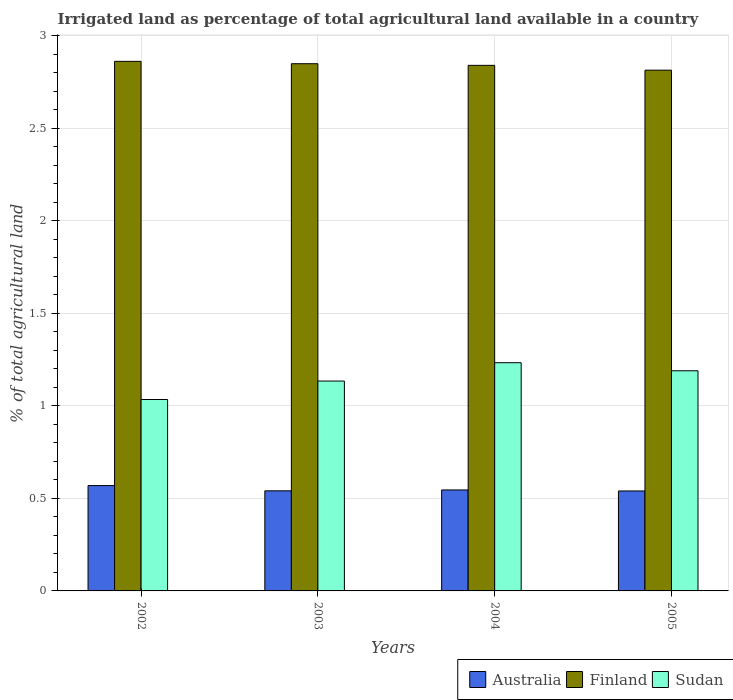Are the number of bars on each tick of the X-axis equal?
Ensure brevity in your answer.  Yes. How many bars are there on the 2nd tick from the left?
Keep it short and to the point. 3. How many bars are there on the 1st tick from the right?
Make the answer very short. 3. What is the label of the 1st group of bars from the left?
Your answer should be compact. 2002. In how many cases, is the number of bars for a given year not equal to the number of legend labels?
Your answer should be compact. 0. What is the percentage of irrigated land in Sudan in 2005?
Give a very brief answer. 1.19. Across all years, what is the maximum percentage of irrigated land in Australia?
Your answer should be very brief. 0.57. Across all years, what is the minimum percentage of irrigated land in Finland?
Offer a very short reply. 2.81. In which year was the percentage of irrigated land in Australia maximum?
Your answer should be very brief. 2002. In which year was the percentage of irrigated land in Australia minimum?
Offer a very short reply. 2005. What is the total percentage of irrigated land in Finland in the graph?
Your answer should be compact. 11.37. What is the difference between the percentage of irrigated land in Finland in 2003 and that in 2004?
Your answer should be very brief. 0.01. What is the difference between the percentage of irrigated land in Finland in 2002 and the percentage of irrigated land in Sudan in 2004?
Give a very brief answer. 1.63. What is the average percentage of irrigated land in Finland per year?
Your answer should be very brief. 2.84. In the year 2002, what is the difference between the percentage of irrigated land in Sudan and percentage of irrigated land in Finland?
Offer a terse response. -1.83. In how many years, is the percentage of irrigated land in Sudan greater than 2.3 %?
Ensure brevity in your answer.  0. What is the ratio of the percentage of irrigated land in Sudan in 2004 to that in 2005?
Your answer should be very brief. 1.04. What is the difference between the highest and the second highest percentage of irrigated land in Australia?
Ensure brevity in your answer.  0.02. What is the difference between the highest and the lowest percentage of irrigated land in Sudan?
Ensure brevity in your answer.  0.2. In how many years, is the percentage of irrigated land in Australia greater than the average percentage of irrigated land in Australia taken over all years?
Provide a succinct answer. 1. Is it the case that in every year, the sum of the percentage of irrigated land in Finland and percentage of irrigated land in Sudan is greater than the percentage of irrigated land in Australia?
Provide a short and direct response. Yes. Are all the bars in the graph horizontal?
Give a very brief answer. No. Are the values on the major ticks of Y-axis written in scientific E-notation?
Your response must be concise. No. How are the legend labels stacked?
Your answer should be compact. Horizontal. What is the title of the graph?
Provide a succinct answer. Irrigated land as percentage of total agricultural land available in a country. Does "Madagascar" appear as one of the legend labels in the graph?
Give a very brief answer. No. What is the label or title of the Y-axis?
Your response must be concise. % of total agricultural land. What is the % of total agricultural land of Australia in 2002?
Provide a succinct answer. 0.57. What is the % of total agricultural land in Finland in 2002?
Make the answer very short. 2.86. What is the % of total agricultural land of Sudan in 2002?
Provide a short and direct response. 1.03. What is the % of total agricultural land of Australia in 2003?
Provide a succinct answer. 0.54. What is the % of total agricultural land in Finland in 2003?
Offer a terse response. 2.85. What is the % of total agricultural land in Sudan in 2003?
Make the answer very short. 1.13. What is the % of total agricultural land in Australia in 2004?
Provide a succinct answer. 0.55. What is the % of total agricultural land in Finland in 2004?
Give a very brief answer. 2.84. What is the % of total agricultural land of Sudan in 2004?
Offer a very short reply. 1.23. What is the % of total agricultural land in Australia in 2005?
Your answer should be compact. 0.54. What is the % of total agricultural land in Finland in 2005?
Offer a very short reply. 2.81. What is the % of total agricultural land of Sudan in 2005?
Offer a terse response. 1.19. Across all years, what is the maximum % of total agricultural land of Australia?
Give a very brief answer. 0.57. Across all years, what is the maximum % of total agricultural land of Finland?
Make the answer very short. 2.86. Across all years, what is the maximum % of total agricultural land in Sudan?
Your response must be concise. 1.23. Across all years, what is the minimum % of total agricultural land of Australia?
Your answer should be very brief. 0.54. Across all years, what is the minimum % of total agricultural land in Finland?
Offer a terse response. 2.81. Across all years, what is the minimum % of total agricultural land in Sudan?
Keep it short and to the point. 1.03. What is the total % of total agricultural land in Australia in the graph?
Ensure brevity in your answer.  2.2. What is the total % of total agricultural land in Finland in the graph?
Your answer should be compact. 11.37. What is the total % of total agricultural land in Sudan in the graph?
Your answer should be very brief. 4.59. What is the difference between the % of total agricultural land of Australia in 2002 and that in 2003?
Offer a very short reply. 0.03. What is the difference between the % of total agricultural land in Finland in 2002 and that in 2003?
Keep it short and to the point. 0.01. What is the difference between the % of total agricultural land in Sudan in 2002 and that in 2003?
Your answer should be very brief. -0.1. What is the difference between the % of total agricultural land in Australia in 2002 and that in 2004?
Offer a very short reply. 0.02. What is the difference between the % of total agricultural land of Finland in 2002 and that in 2004?
Your answer should be very brief. 0.02. What is the difference between the % of total agricultural land in Sudan in 2002 and that in 2004?
Make the answer very short. -0.2. What is the difference between the % of total agricultural land in Australia in 2002 and that in 2005?
Your response must be concise. 0.03. What is the difference between the % of total agricultural land of Finland in 2002 and that in 2005?
Make the answer very short. 0.05. What is the difference between the % of total agricultural land of Sudan in 2002 and that in 2005?
Your response must be concise. -0.16. What is the difference between the % of total agricultural land in Australia in 2003 and that in 2004?
Give a very brief answer. -0. What is the difference between the % of total agricultural land of Finland in 2003 and that in 2004?
Ensure brevity in your answer.  0.01. What is the difference between the % of total agricultural land of Sudan in 2003 and that in 2004?
Ensure brevity in your answer.  -0.1. What is the difference between the % of total agricultural land in Australia in 2003 and that in 2005?
Your response must be concise. 0. What is the difference between the % of total agricultural land in Finland in 2003 and that in 2005?
Keep it short and to the point. 0.03. What is the difference between the % of total agricultural land of Sudan in 2003 and that in 2005?
Make the answer very short. -0.06. What is the difference between the % of total agricultural land in Australia in 2004 and that in 2005?
Keep it short and to the point. 0.01. What is the difference between the % of total agricultural land of Finland in 2004 and that in 2005?
Offer a terse response. 0.03. What is the difference between the % of total agricultural land in Sudan in 2004 and that in 2005?
Your answer should be very brief. 0.04. What is the difference between the % of total agricultural land of Australia in 2002 and the % of total agricultural land of Finland in 2003?
Your response must be concise. -2.28. What is the difference between the % of total agricultural land in Australia in 2002 and the % of total agricultural land in Sudan in 2003?
Offer a terse response. -0.56. What is the difference between the % of total agricultural land of Finland in 2002 and the % of total agricultural land of Sudan in 2003?
Your response must be concise. 1.73. What is the difference between the % of total agricultural land in Australia in 2002 and the % of total agricultural land in Finland in 2004?
Make the answer very short. -2.27. What is the difference between the % of total agricultural land of Australia in 2002 and the % of total agricultural land of Sudan in 2004?
Offer a terse response. -0.66. What is the difference between the % of total agricultural land in Finland in 2002 and the % of total agricultural land in Sudan in 2004?
Offer a very short reply. 1.63. What is the difference between the % of total agricultural land in Australia in 2002 and the % of total agricultural land in Finland in 2005?
Provide a succinct answer. -2.25. What is the difference between the % of total agricultural land of Australia in 2002 and the % of total agricultural land of Sudan in 2005?
Make the answer very short. -0.62. What is the difference between the % of total agricultural land in Finland in 2002 and the % of total agricultural land in Sudan in 2005?
Your answer should be compact. 1.67. What is the difference between the % of total agricultural land of Australia in 2003 and the % of total agricultural land of Finland in 2004?
Your answer should be compact. -2.3. What is the difference between the % of total agricultural land of Australia in 2003 and the % of total agricultural land of Sudan in 2004?
Your answer should be compact. -0.69. What is the difference between the % of total agricultural land in Finland in 2003 and the % of total agricultural land in Sudan in 2004?
Your response must be concise. 1.62. What is the difference between the % of total agricultural land in Australia in 2003 and the % of total agricultural land in Finland in 2005?
Your answer should be very brief. -2.27. What is the difference between the % of total agricultural land of Australia in 2003 and the % of total agricultural land of Sudan in 2005?
Your response must be concise. -0.65. What is the difference between the % of total agricultural land of Finland in 2003 and the % of total agricultural land of Sudan in 2005?
Offer a very short reply. 1.66. What is the difference between the % of total agricultural land in Australia in 2004 and the % of total agricultural land in Finland in 2005?
Offer a terse response. -2.27. What is the difference between the % of total agricultural land of Australia in 2004 and the % of total agricultural land of Sudan in 2005?
Provide a succinct answer. -0.64. What is the difference between the % of total agricultural land of Finland in 2004 and the % of total agricultural land of Sudan in 2005?
Your answer should be very brief. 1.65. What is the average % of total agricultural land in Australia per year?
Ensure brevity in your answer.  0.55. What is the average % of total agricultural land of Finland per year?
Give a very brief answer. 2.84. What is the average % of total agricultural land in Sudan per year?
Offer a very short reply. 1.15. In the year 2002, what is the difference between the % of total agricultural land in Australia and % of total agricultural land in Finland?
Give a very brief answer. -2.29. In the year 2002, what is the difference between the % of total agricultural land of Australia and % of total agricultural land of Sudan?
Make the answer very short. -0.47. In the year 2002, what is the difference between the % of total agricultural land in Finland and % of total agricultural land in Sudan?
Ensure brevity in your answer.  1.83. In the year 2003, what is the difference between the % of total agricultural land of Australia and % of total agricultural land of Finland?
Your response must be concise. -2.31. In the year 2003, what is the difference between the % of total agricultural land of Australia and % of total agricultural land of Sudan?
Ensure brevity in your answer.  -0.59. In the year 2003, what is the difference between the % of total agricultural land of Finland and % of total agricultural land of Sudan?
Offer a very short reply. 1.72. In the year 2004, what is the difference between the % of total agricultural land in Australia and % of total agricultural land in Finland?
Your answer should be very brief. -2.29. In the year 2004, what is the difference between the % of total agricultural land of Australia and % of total agricultural land of Sudan?
Keep it short and to the point. -0.69. In the year 2004, what is the difference between the % of total agricultural land in Finland and % of total agricultural land in Sudan?
Provide a succinct answer. 1.61. In the year 2005, what is the difference between the % of total agricultural land of Australia and % of total agricultural land of Finland?
Your answer should be compact. -2.27. In the year 2005, what is the difference between the % of total agricultural land in Australia and % of total agricultural land in Sudan?
Keep it short and to the point. -0.65. In the year 2005, what is the difference between the % of total agricultural land of Finland and % of total agricultural land of Sudan?
Give a very brief answer. 1.62. What is the ratio of the % of total agricultural land of Australia in 2002 to that in 2003?
Your answer should be very brief. 1.05. What is the ratio of the % of total agricultural land in Finland in 2002 to that in 2003?
Your answer should be compact. 1. What is the ratio of the % of total agricultural land of Sudan in 2002 to that in 2003?
Ensure brevity in your answer.  0.91. What is the ratio of the % of total agricultural land of Australia in 2002 to that in 2004?
Offer a terse response. 1.04. What is the ratio of the % of total agricultural land in Finland in 2002 to that in 2004?
Ensure brevity in your answer.  1.01. What is the ratio of the % of total agricultural land of Sudan in 2002 to that in 2004?
Your answer should be very brief. 0.84. What is the ratio of the % of total agricultural land in Australia in 2002 to that in 2005?
Offer a very short reply. 1.05. What is the ratio of the % of total agricultural land of Finland in 2002 to that in 2005?
Provide a short and direct response. 1.02. What is the ratio of the % of total agricultural land of Sudan in 2002 to that in 2005?
Keep it short and to the point. 0.87. What is the ratio of the % of total agricultural land in Australia in 2003 to that in 2004?
Your answer should be very brief. 0.99. What is the ratio of the % of total agricultural land of Finland in 2003 to that in 2004?
Provide a succinct answer. 1. What is the ratio of the % of total agricultural land of Sudan in 2003 to that in 2004?
Provide a succinct answer. 0.92. What is the ratio of the % of total agricultural land of Finland in 2003 to that in 2005?
Provide a short and direct response. 1.01. What is the ratio of the % of total agricultural land in Sudan in 2003 to that in 2005?
Offer a terse response. 0.95. What is the ratio of the % of total agricultural land in Australia in 2004 to that in 2005?
Your answer should be compact. 1.01. What is the ratio of the % of total agricultural land in Finland in 2004 to that in 2005?
Keep it short and to the point. 1.01. What is the ratio of the % of total agricultural land of Sudan in 2004 to that in 2005?
Offer a very short reply. 1.04. What is the difference between the highest and the second highest % of total agricultural land in Australia?
Your answer should be compact. 0.02. What is the difference between the highest and the second highest % of total agricultural land in Finland?
Your answer should be compact. 0.01. What is the difference between the highest and the second highest % of total agricultural land in Sudan?
Your answer should be compact. 0.04. What is the difference between the highest and the lowest % of total agricultural land of Australia?
Your response must be concise. 0.03. What is the difference between the highest and the lowest % of total agricultural land of Finland?
Give a very brief answer. 0.05. What is the difference between the highest and the lowest % of total agricultural land of Sudan?
Give a very brief answer. 0.2. 